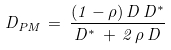<formula> <loc_0><loc_0><loc_500><loc_500>D _ { P M } \, = \, \frac { ( 1 - \rho ) \, D \, D ^ { * } } { D ^ { * } \, + \, 2 \, \rho \, D }</formula> 